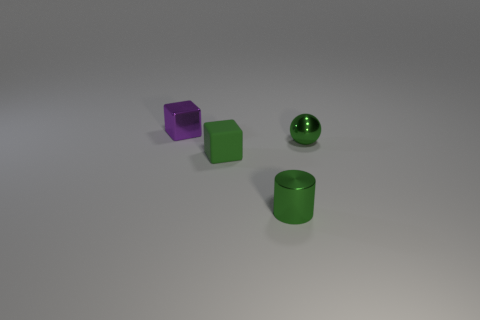There is a rubber object that is the same shape as the small purple shiny thing; what is its color?
Your answer should be very brief. Green. Are there any other purple things that have the same shape as the matte thing?
Provide a succinct answer. Yes. Are there an equal number of green things that are in front of the green cylinder and tiny shiny objects that are on the left side of the purple object?
Provide a short and direct response. Yes. What color is the cube in front of the block to the left of the small cube on the right side of the tiny purple object?
Your answer should be compact. Green. What number of tiny shiny objects are in front of the small purple thing and behind the small green rubber block?
Keep it short and to the point. 1. There is a cube in front of the metal block; is it the same color as the tiny ball right of the small green metallic cylinder?
Keep it short and to the point. Yes. Are there any other things that have the same material as the green cube?
Provide a succinct answer. No. There is a metal ball; are there any tiny shiny objects behind it?
Provide a short and direct response. Yes. Are there the same number of small purple shiny cubes in front of the small metal sphere and cylinders?
Give a very brief answer. No. There is a object in front of the small green thing to the left of the small metallic cylinder; are there any things to the right of it?
Your answer should be compact. Yes. 